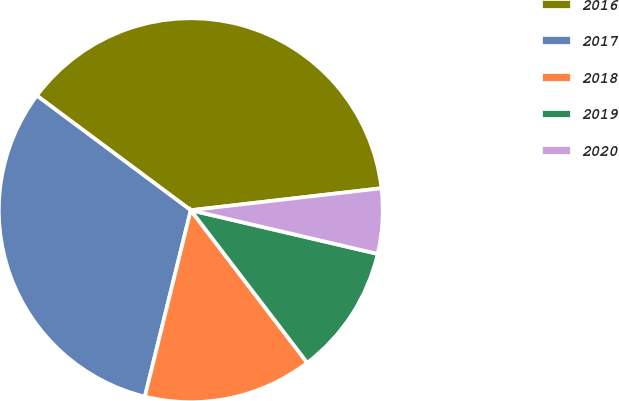<chart> <loc_0><loc_0><loc_500><loc_500><pie_chart><fcel>2016<fcel>2017<fcel>2018<fcel>2019<fcel>2020<nl><fcel>37.99%<fcel>31.34%<fcel>14.22%<fcel>10.97%<fcel>5.48%<nl></chart> 